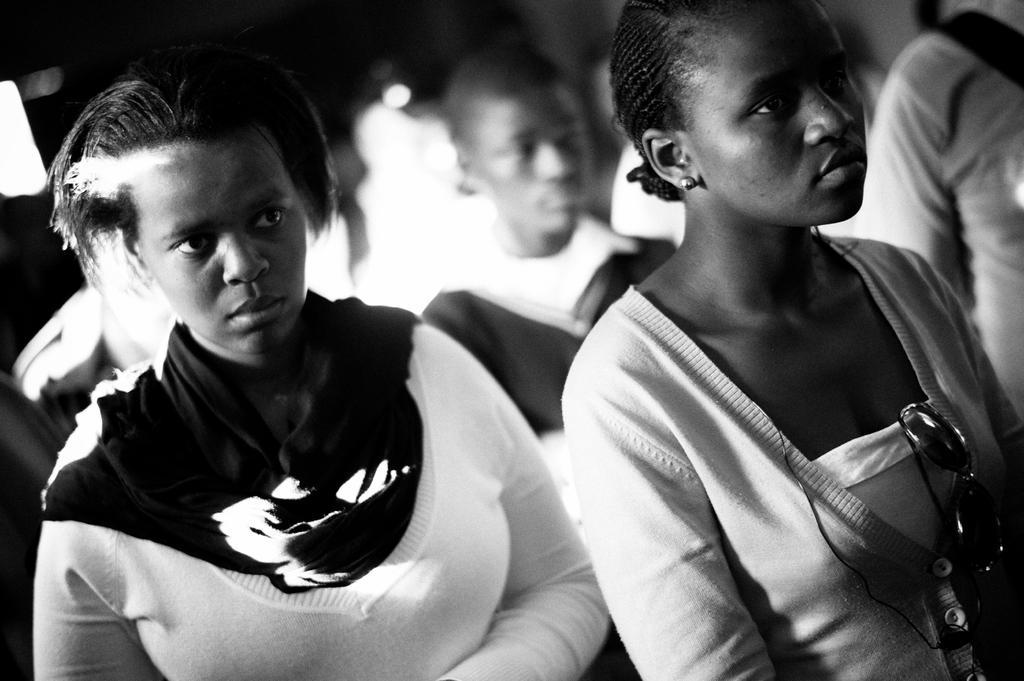Please provide a concise description of this image. In this image I can see few people are standing. On the right side of the image I can see a wire and a shades. I can see this image is black and white in color. I can also see this image is little bit blurry. 